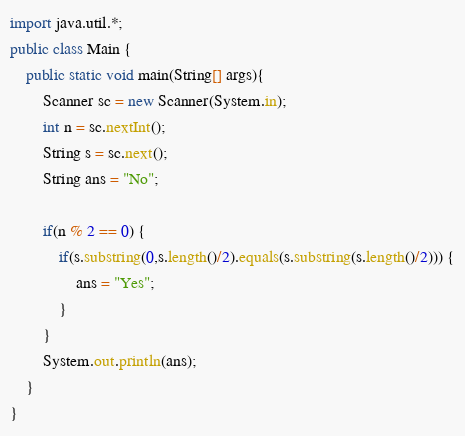Convert code to text. <code><loc_0><loc_0><loc_500><loc_500><_Java_>import java.util.*;
public class Main { 
	public static void main(String[] args){
		Scanner sc = new Scanner(System.in);
		int n = sc.nextInt(); 
		String s = sc.next();
		String ans = "No";
		
		if(n % 2 == 0) {
			if(s.substring(0,s.length()/2).equals(s.substring(s.length()/2))) {
				ans = "Yes";
			}
		}
		System.out.println(ans);
	}	
}</code> 